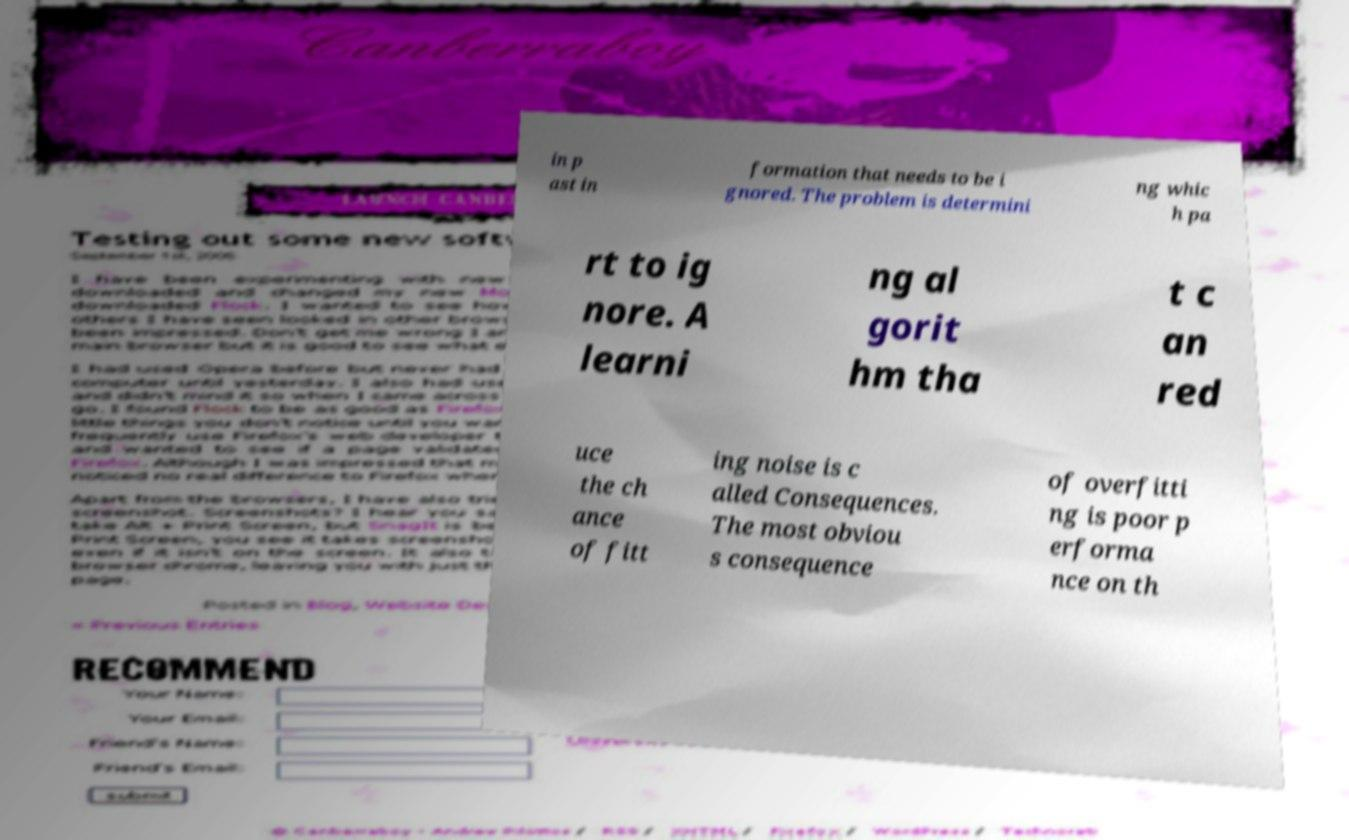There's text embedded in this image that I need extracted. Can you transcribe it verbatim? in p ast in formation that needs to be i gnored. The problem is determini ng whic h pa rt to ig nore. A learni ng al gorit hm tha t c an red uce the ch ance of fitt ing noise is c alled Consequences. The most obviou s consequence of overfitti ng is poor p erforma nce on th 